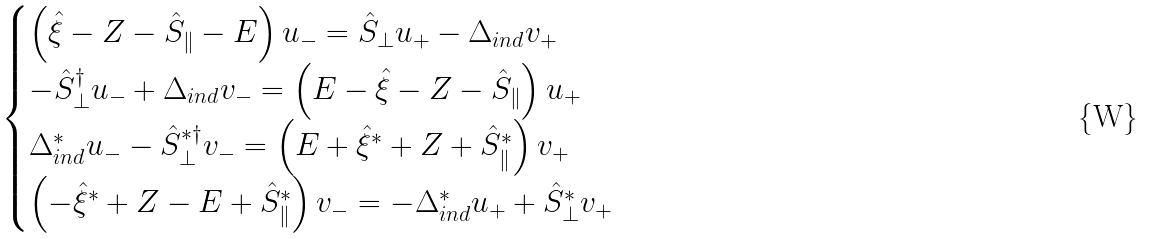Convert formula to latex. <formula><loc_0><loc_0><loc_500><loc_500>\begin{cases} \left ( \hat { \xi } - Z - \hat { S } _ { \| } - E \right ) u _ { - } = \hat { S } _ { \perp } u _ { + } - \Delta _ { i n d } v _ { + } \\ - \hat { S } _ { \perp } ^ { \dagger } u _ { - } + \Delta _ { i n d } v _ { - } = \left ( E - \hat { \xi } - Z - \hat { S } _ { \| } \right ) u _ { + } \\ \Delta _ { i n d } ^ { * } u _ { - } - \hat { S } _ { \perp } ^ { * \dagger } v _ { - } = \left ( E + \hat { \xi } ^ { * } + Z + \hat { S } _ { \| } ^ { * } \right ) v _ { + } \\ \left ( - \hat { \xi } ^ { * } + Z - E + \hat { S } _ { \| } ^ { * } \right ) v _ { - } = - \Delta _ { i n d } ^ { * } u _ { + } + \hat { S } _ { \perp } ^ { * } v _ { + } \end{cases}</formula> 